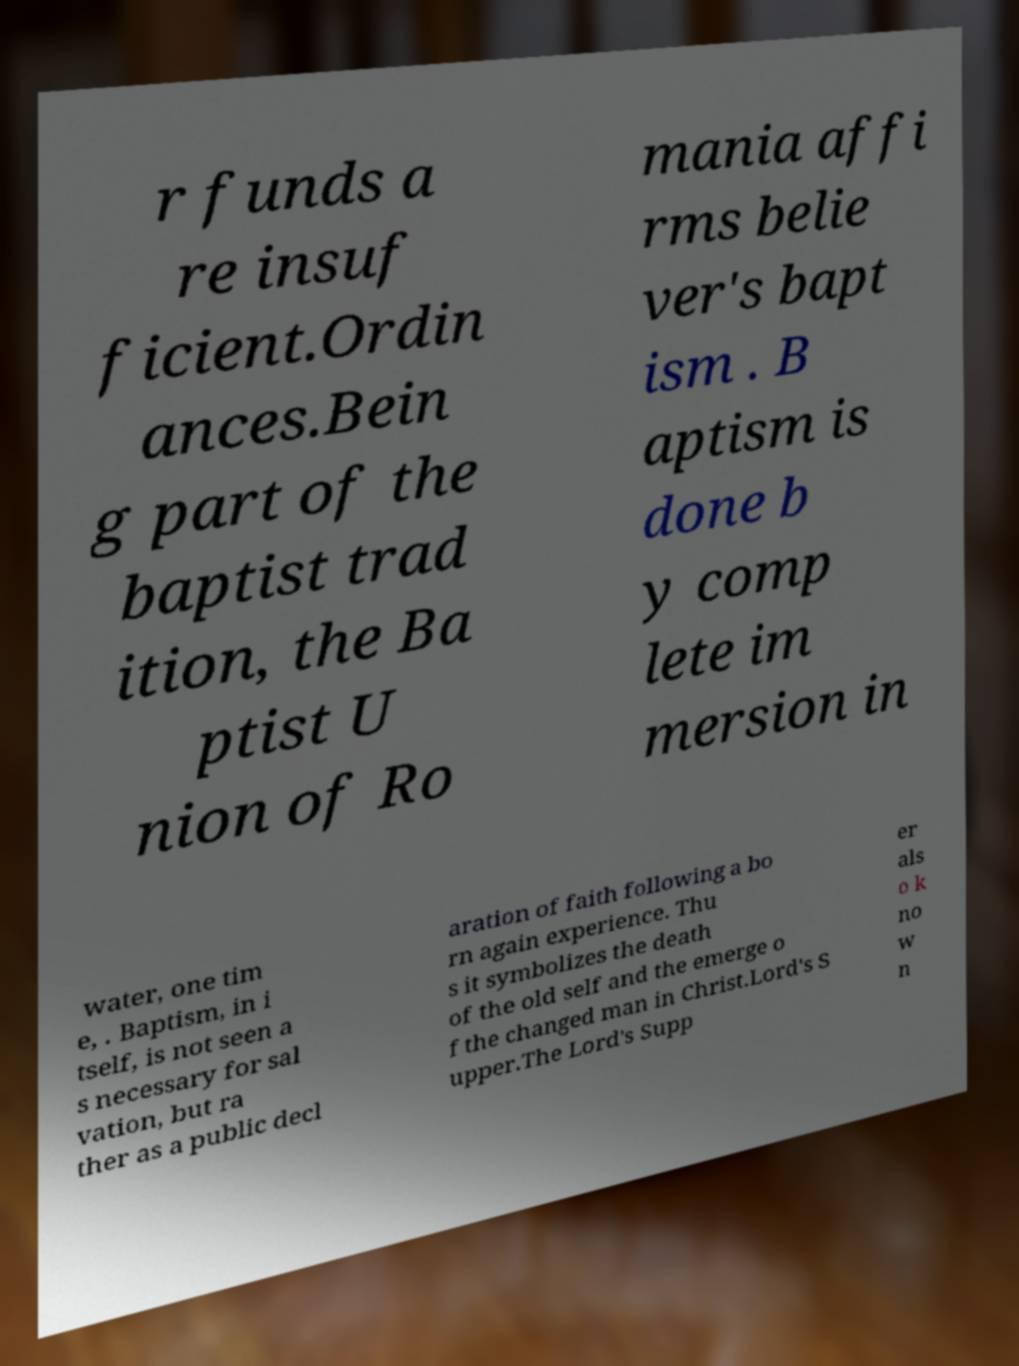Can you read and provide the text displayed in the image?This photo seems to have some interesting text. Can you extract and type it out for me? r funds a re insuf ficient.Ordin ances.Bein g part of the baptist trad ition, the Ba ptist U nion of Ro mania affi rms belie ver's bapt ism . B aptism is done b y comp lete im mersion in water, one tim e, . Baptism, in i tself, is not seen a s necessary for sal vation, but ra ther as a public decl aration of faith following a bo rn again experience. Thu s it symbolizes the death of the old self and the emerge o f the changed man in Christ.Lord's S upper.The Lord's Supp er als o k no w n 